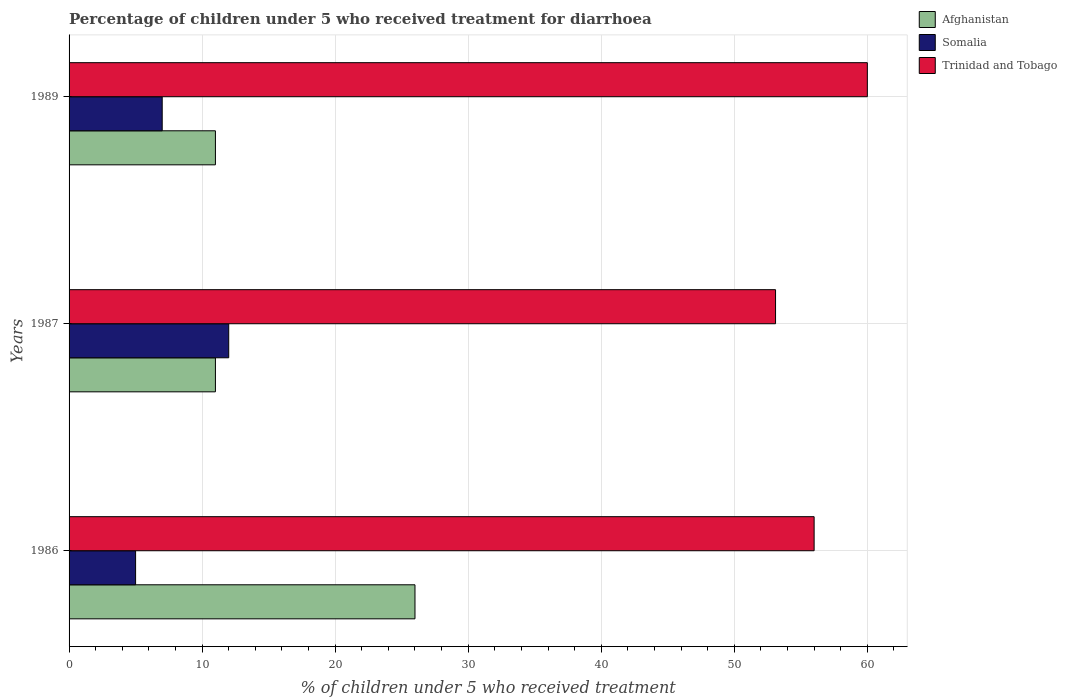How many groups of bars are there?
Make the answer very short. 3. How many bars are there on the 1st tick from the top?
Your answer should be very brief. 3. How many bars are there on the 2nd tick from the bottom?
Make the answer very short. 3. In how many cases, is the number of bars for a given year not equal to the number of legend labels?
Ensure brevity in your answer.  0. In which year was the percentage of children who received treatment for diarrhoea  in Trinidad and Tobago maximum?
Your answer should be very brief. 1989. In which year was the percentage of children who received treatment for diarrhoea  in Somalia minimum?
Ensure brevity in your answer.  1986. What is the total percentage of children who received treatment for diarrhoea  in Trinidad and Tobago in the graph?
Offer a very short reply. 169.1. What is the difference between the percentage of children who received treatment for diarrhoea  in Somalia in 1987 and the percentage of children who received treatment for diarrhoea  in Afghanistan in 1986?
Your answer should be very brief. -14. What is the average percentage of children who received treatment for diarrhoea  in Afghanistan per year?
Ensure brevity in your answer.  16. In how many years, is the percentage of children who received treatment for diarrhoea  in Somalia greater than 26 %?
Keep it short and to the point. 0. What is the ratio of the percentage of children who received treatment for diarrhoea  in Afghanistan in 1987 to that in 1989?
Your answer should be compact. 1. Is the percentage of children who received treatment for diarrhoea  in Trinidad and Tobago in 1987 less than that in 1989?
Ensure brevity in your answer.  Yes. What is the difference between the highest and the second highest percentage of children who received treatment for diarrhoea  in Somalia?
Give a very brief answer. 5. In how many years, is the percentage of children who received treatment for diarrhoea  in Trinidad and Tobago greater than the average percentage of children who received treatment for diarrhoea  in Trinidad and Tobago taken over all years?
Make the answer very short. 1. What does the 3rd bar from the top in 1987 represents?
Provide a succinct answer. Afghanistan. What does the 1st bar from the bottom in 1987 represents?
Provide a succinct answer. Afghanistan. Are all the bars in the graph horizontal?
Your answer should be very brief. Yes. How many years are there in the graph?
Provide a succinct answer. 3. What is the difference between two consecutive major ticks on the X-axis?
Your answer should be compact. 10. Where does the legend appear in the graph?
Provide a succinct answer. Top right. How many legend labels are there?
Your answer should be compact. 3. What is the title of the graph?
Give a very brief answer. Percentage of children under 5 who received treatment for diarrhoea. Does "New Zealand" appear as one of the legend labels in the graph?
Give a very brief answer. No. What is the label or title of the X-axis?
Provide a succinct answer. % of children under 5 who received treatment. What is the label or title of the Y-axis?
Give a very brief answer. Years. What is the % of children under 5 who received treatment of Trinidad and Tobago in 1986?
Offer a very short reply. 56. What is the % of children under 5 who received treatment of Trinidad and Tobago in 1987?
Your response must be concise. 53.1. What is the % of children under 5 who received treatment in Afghanistan in 1989?
Provide a short and direct response. 11. What is the % of children under 5 who received treatment of Somalia in 1989?
Provide a succinct answer. 7. Across all years, what is the minimum % of children under 5 who received treatment of Trinidad and Tobago?
Offer a terse response. 53.1. What is the total % of children under 5 who received treatment of Afghanistan in the graph?
Offer a terse response. 48. What is the total % of children under 5 who received treatment of Trinidad and Tobago in the graph?
Ensure brevity in your answer.  169.1. What is the difference between the % of children under 5 who received treatment of Afghanistan in 1986 and that in 1989?
Ensure brevity in your answer.  15. What is the difference between the % of children under 5 who received treatment of Somalia in 1986 and that in 1989?
Your answer should be very brief. -2. What is the difference between the % of children under 5 who received treatment of Somalia in 1987 and that in 1989?
Offer a terse response. 5. What is the difference between the % of children under 5 who received treatment in Trinidad and Tobago in 1987 and that in 1989?
Offer a very short reply. -6.9. What is the difference between the % of children under 5 who received treatment of Afghanistan in 1986 and the % of children under 5 who received treatment of Trinidad and Tobago in 1987?
Offer a very short reply. -27.1. What is the difference between the % of children under 5 who received treatment of Somalia in 1986 and the % of children under 5 who received treatment of Trinidad and Tobago in 1987?
Ensure brevity in your answer.  -48.1. What is the difference between the % of children under 5 who received treatment in Afghanistan in 1986 and the % of children under 5 who received treatment in Trinidad and Tobago in 1989?
Ensure brevity in your answer.  -34. What is the difference between the % of children under 5 who received treatment of Somalia in 1986 and the % of children under 5 who received treatment of Trinidad and Tobago in 1989?
Offer a terse response. -55. What is the difference between the % of children under 5 who received treatment of Afghanistan in 1987 and the % of children under 5 who received treatment of Trinidad and Tobago in 1989?
Your answer should be very brief. -49. What is the difference between the % of children under 5 who received treatment in Somalia in 1987 and the % of children under 5 who received treatment in Trinidad and Tobago in 1989?
Ensure brevity in your answer.  -48. What is the average % of children under 5 who received treatment in Afghanistan per year?
Your answer should be very brief. 16. What is the average % of children under 5 who received treatment of Trinidad and Tobago per year?
Provide a succinct answer. 56.37. In the year 1986, what is the difference between the % of children under 5 who received treatment in Somalia and % of children under 5 who received treatment in Trinidad and Tobago?
Your response must be concise. -51. In the year 1987, what is the difference between the % of children under 5 who received treatment of Afghanistan and % of children under 5 who received treatment of Trinidad and Tobago?
Give a very brief answer. -42.1. In the year 1987, what is the difference between the % of children under 5 who received treatment of Somalia and % of children under 5 who received treatment of Trinidad and Tobago?
Ensure brevity in your answer.  -41.1. In the year 1989, what is the difference between the % of children under 5 who received treatment in Afghanistan and % of children under 5 who received treatment in Somalia?
Your response must be concise. 4. In the year 1989, what is the difference between the % of children under 5 who received treatment of Afghanistan and % of children under 5 who received treatment of Trinidad and Tobago?
Make the answer very short. -49. In the year 1989, what is the difference between the % of children under 5 who received treatment in Somalia and % of children under 5 who received treatment in Trinidad and Tobago?
Offer a terse response. -53. What is the ratio of the % of children under 5 who received treatment in Afghanistan in 1986 to that in 1987?
Offer a terse response. 2.36. What is the ratio of the % of children under 5 who received treatment in Somalia in 1986 to that in 1987?
Provide a short and direct response. 0.42. What is the ratio of the % of children under 5 who received treatment in Trinidad and Tobago in 1986 to that in 1987?
Make the answer very short. 1.05. What is the ratio of the % of children under 5 who received treatment in Afghanistan in 1986 to that in 1989?
Offer a terse response. 2.36. What is the ratio of the % of children under 5 who received treatment in Somalia in 1986 to that in 1989?
Your response must be concise. 0.71. What is the ratio of the % of children under 5 who received treatment of Trinidad and Tobago in 1986 to that in 1989?
Keep it short and to the point. 0.93. What is the ratio of the % of children under 5 who received treatment of Afghanistan in 1987 to that in 1989?
Ensure brevity in your answer.  1. What is the ratio of the % of children under 5 who received treatment of Somalia in 1987 to that in 1989?
Your response must be concise. 1.71. What is the ratio of the % of children under 5 who received treatment in Trinidad and Tobago in 1987 to that in 1989?
Make the answer very short. 0.89. What is the difference between the highest and the second highest % of children under 5 who received treatment in Trinidad and Tobago?
Ensure brevity in your answer.  4. What is the difference between the highest and the lowest % of children under 5 who received treatment of Trinidad and Tobago?
Your answer should be very brief. 6.9. 